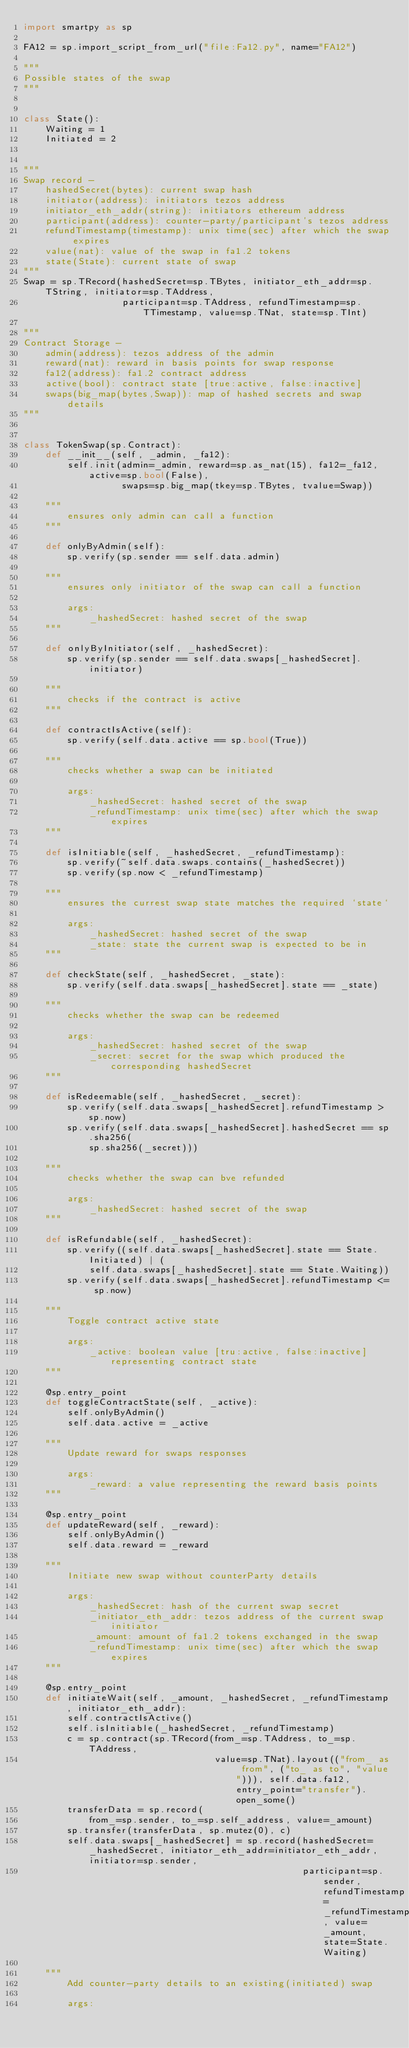Convert code to text. <code><loc_0><loc_0><loc_500><loc_500><_Python_>import smartpy as sp

FA12 = sp.import_script_from_url("file:Fa12.py", name="FA12")

"""
Possible states of the swap
"""


class State():
    Waiting = 1
    Initiated = 2


"""
Swap record - 
    hashedSecret(bytes): current swap hash
    initiator(address): initiators tezos address
    initiator_eth_addr(string): initiators ethereum address
    participant(address): counter-party/participant's tezos address
    refundTimestamp(timestamp): unix time(sec) after which the swap expires
    value(nat): value of the swap in fa1.2 tokens
    state(State): current state of swap
"""
Swap = sp.TRecord(hashedSecret=sp.TBytes, initiator_eth_addr=sp.TString, initiator=sp.TAddress,
                  participant=sp.TAddress, refundTimestamp=sp.TTimestamp, value=sp.TNat, state=sp.TInt)

"""
Contract Storage -
    admin(address): tezos address of the admin
    reward(nat): reward in basis points for swap response
    fa12(address): fa1.2 contract address
    active(bool): contract state [true:active, false:inactive]
    swaps(big_map(bytes,Swap)): map of hashed secrets and swap details
"""


class TokenSwap(sp.Contract):
    def __init__(self, _admin, _fa12):
        self.init(admin=_admin, reward=sp.as_nat(15), fa12=_fa12, active=sp.bool(False),
                  swaps=sp.big_map(tkey=sp.TBytes, tvalue=Swap))

    """
        ensures only admin can call a function 
    """

    def onlyByAdmin(self):
        sp.verify(sp.sender == self.data.admin)

    """
        ensures only initiator of the swap can call a function 
        
        args:
            _hashedSecret: hashed secret of the swap
    """

    def onlyByInitiator(self, _hashedSecret):
        sp.verify(sp.sender == self.data.swaps[_hashedSecret].initiator)

    """
        checks if the contract is active
    """

    def contractIsActive(self):
        sp.verify(self.data.active == sp.bool(True))

    """
        checks whether a swap can be initiated

        args: 
            _hashedSecret: hashed secret of the swap
            _refundTimestamp: unix time(sec) after which the swap expires
    """

    def isInitiable(self, _hashedSecret, _refundTimestamp):
        sp.verify(~self.data.swaps.contains(_hashedSecret))
        sp.verify(sp.now < _refundTimestamp)

    """
        ensures the currest swap state matches the required `state`

        args: 
            _hashedSecret: hashed secret of the swap
            _state: state the current swap is expected to be in
    """

    def checkState(self, _hashedSecret, _state):
        sp.verify(self.data.swaps[_hashedSecret].state == _state)

    """
        checks whether the swap can be redeemed

        args: 
            _hashedSecret: hashed secret of the swap
            _secret: secret for the swap which produced the corresponding hashedSecret
    """

    def isRedeemable(self, _hashedSecret, _secret):
        sp.verify(self.data.swaps[_hashedSecret].refundTimestamp > sp.now)
        sp.verify(self.data.swaps[_hashedSecret].hashedSecret == sp.sha256(
            sp.sha256(_secret)))

    """
        checks whether the swap can bve refunded

        args: 
            _hashedSecret: hashed secret of the swap
    """

    def isRefundable(self, _hashedSecret):
        sp.verify((self.data.swaps[_hashedSecret].state == State.Initiated) | (
            self.data.swaps[_hashedSecret].state == State.Waiting))
        sp.verify(self.data.swaps[_hashedSecret].refundTimestamp <= sp.now)

    """
        Toggle contract active state

        args:
            _active: boolean value [tru:active, false:inactive] representing contract state
    """

    @sp.entry_point
    def toggleContractState(self, _active):
        self.onlyByAdmin()
        self.data.active = _active

    """
        Update reward for swaps responses

        args:
            _reward: a value representing the reward basis points
    """

    @sp.entry_point
    def updateReward(self, _reward):
        self.onlyByAdmin()
        self.data.reward = _reward

    """
        Initiate new swap without counterParty details

        args:
            _hashedSecret: hash of the current swap secret
            _initiator_eth_addr: tezos address of the current swap initiator
            _amount: amount of fa1.2 tokens exchanged in the swap
            _refundTimestamp: unix time(sec) after which the swap expires
    """

    @sp.entry_point
    def initiateWait(self, _amount, _hashedSecret, _refundTimestamp, initiator_eth_addr):
        self.contractIsActive()
        self.isInitiable(_hashedSecret, _refundTimestamp)
        c = sp.contract(sp.TRecord(from_=sp.TAddress, to_=sp.TAddress,
                                   value=sp.TNat).layout(("from_ as from", ("to_ as to", "value"))), self.data.fa12, entry_point="transfer").open_some()
        transferData = sp.record(
            from_=sp.sender, to_=sp.self_address, value=_amount)
        sp.transfer(transferData, sp.mutez(0), c)
        self.data.swaps[_hashedSecret] = sp.record(hashedSecret=_hashedSecret, initiator_eth_addr=initiator_eth_addr, initiator=sp.sender,
                                                   participant=sp.sender, refundTimestamp=_refundTimestamp, value=_amount, state=State.Waiting)

    """
        Add counter-party details to an existing(initiated) swap

        args:</code> 